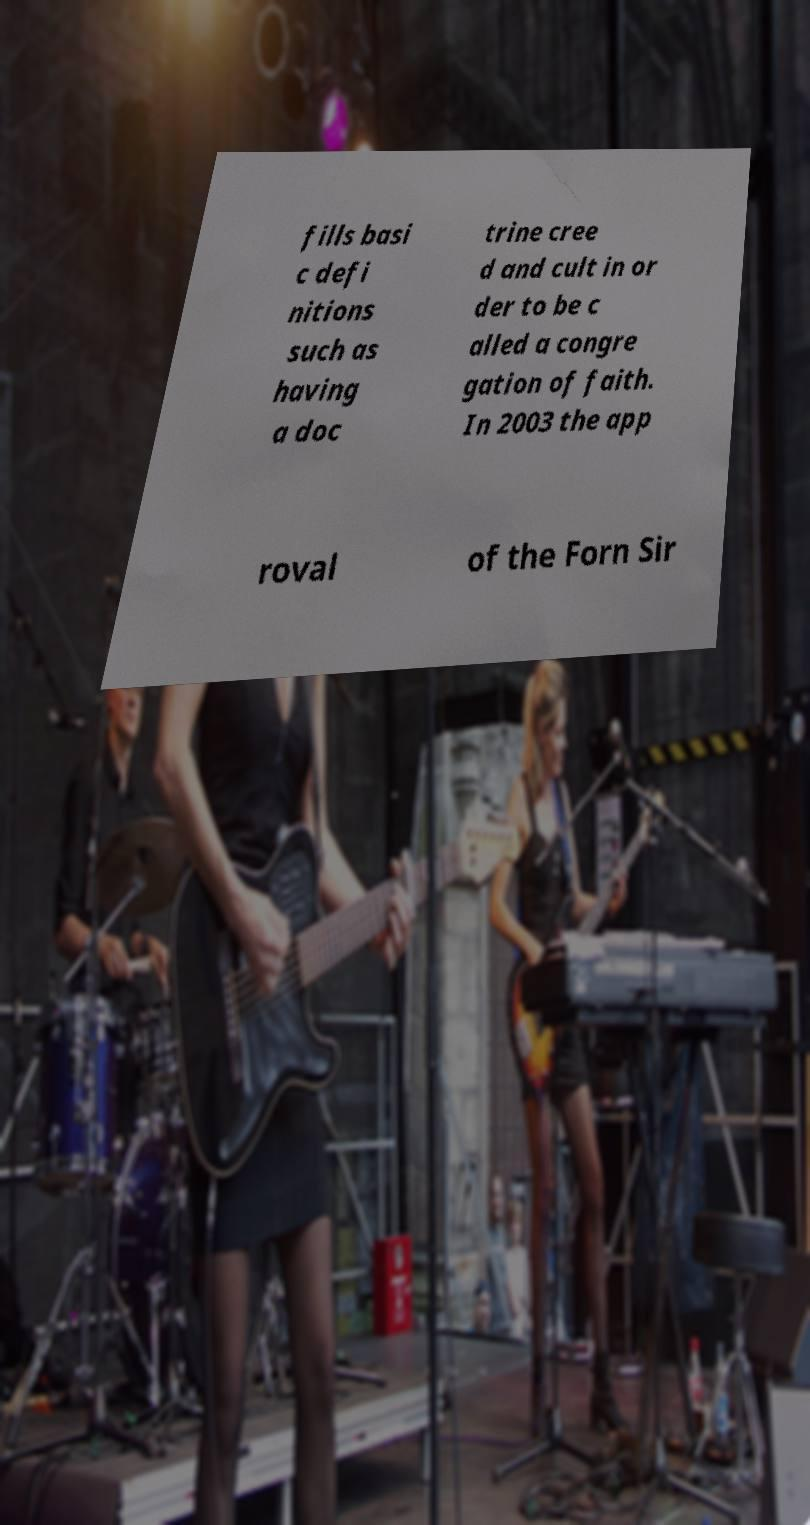For documentation purposes, I need the text within this image transcribed. Could you provide that? fills basi c defi nitions such as having a doc trine cree d and cult in or der to be c alled a congre gation of faith. In 2003 the app roval of the Forn Sir 